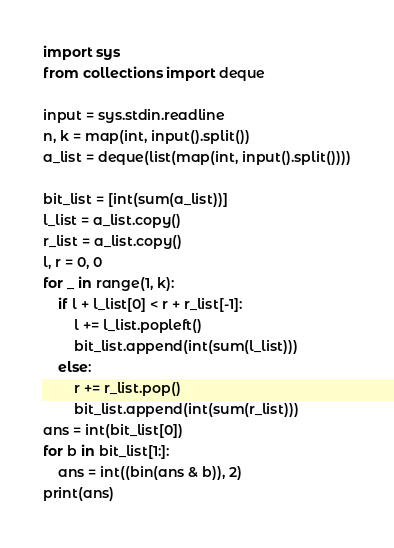<code> <loc_0><loc_0><loc_500><loc_500><_Python_>import sys
from collections import deque

input = sys.stdin.readline
n, k = map(int, input().split())
a_list = deque(list(map(int, input().split())))

bit_list = [int(sum(a_list))]
l_list = a_list.copy()
r_list = a_list.copy()
l, r = 0, 0
for _ in range(1, k):
    if l + l_list[0] < r + r_list[-1]:
        l += l_list.popleft()
        bit_list.append(int(sum(l_list)))
    else:
        r += r_list.pop()
        bit_list.append(int(sum(r_list)))
ans = int(bit_list[0])
for b in bit_list[1:]:
    ans = int((bin(ans & b)), 2)
print(ans)
</code> 